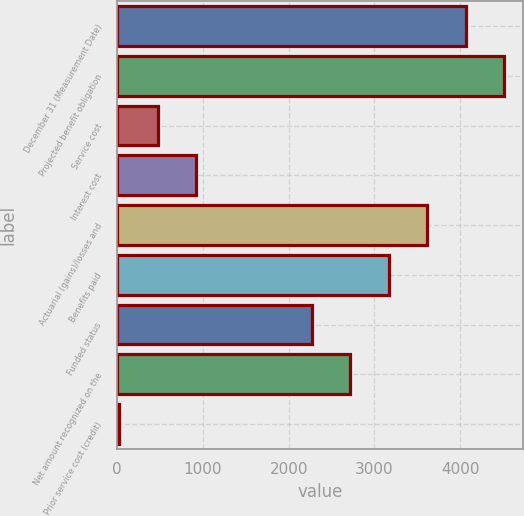Convert chart to OTSL. <chart><loc_0><loc_0><loc_500><loc_500><bar_chart><fcel>December 31 (Measurement Date)<fcel>Projected benefit obligation<fcel>Service cost<fcel>Interest cost<fcel>Actuarial (gains)/losses and<fcel>Benefits paid<fcel>Funded status<fcel>Net amount recognized on the<fcel>Prior service cost (credit)<nl><fcel>4063.1<fcel>4512<fcel>471.9<fcel>920.8<fcel>3614.2<fcel>3165.3<fcel>2267.5<fcel>2716.4<fcel>23<nl></chart> 